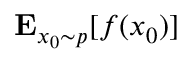Convert formula to latex. <formula><loc_0><loc_0><loc_500><loc_500>E _ { { x _ { 0 } } \sim p } [ f ( x _ { 0 } ) ]</formula> 